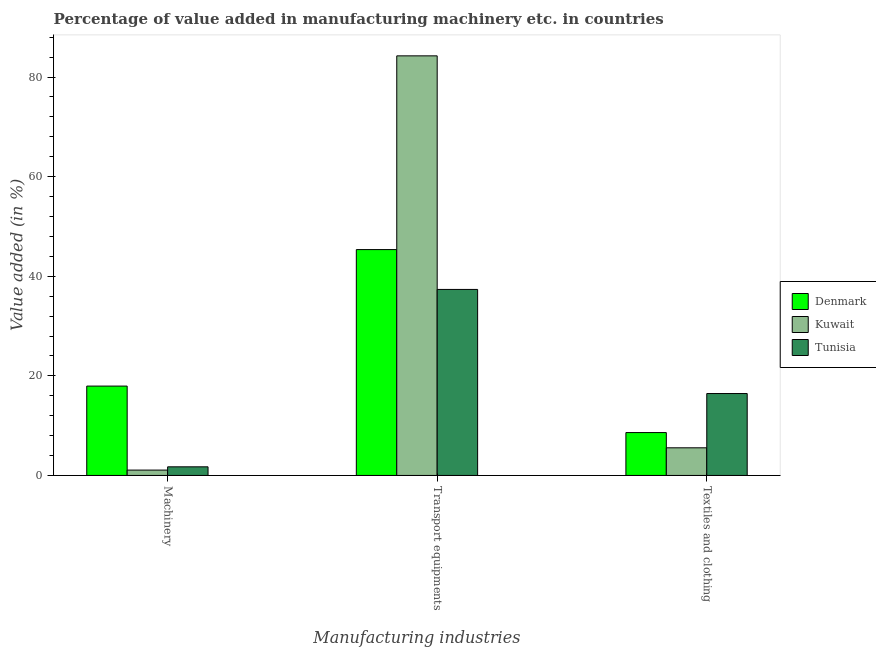How many groups of bars are there?
Your response must be concise. 3. How many bars are there on the 3rd tick from the right?
Your response must be concise. 3. What is the label of the 3rd group of bars from the left?
Provide a short and direct response. Textiles and clothing. What is the value added in manufacturing textile and clothing in Denmark?
Keep it short and to the point. 8.61. Across all countries, what is the maximum value added in manufacturing machinery?
Ensure brevity in your answer.  17.94. Across all countries, what is the minimum value added in manufacturing machinery?
Your answer should be compact. 1.08. In which country was the value added in manufacturing transport equipments maximum?
Keep it short and to the point. Kuwait. In which country was the value added in manufacturing machinery minimum?
Your answer should be compact. Kuwait. What is the total value added in manufacturing textile and clothing in the graph?
Your answer should be compact. 30.6. What is the difference between the value added in manufacturing textile and clothing in Tunisia and that in Denmark?
Give a very brief answer. 7.84. What is the difference between the value added in manufacturing transport equipments in Kuwait and the value added in manufacturing machinery in Denmark?
Give a very brief answer. 66.32. What is the average value added in manufacturing textile and clothing per country?
Your answer should be compact. 10.2. What is the difference between the value added in manufacturing machinery and value added in manufacturing transport equipments in Tunisia?
Offer a very short reply. -35.62. What is the ratio of the value added in manufacturing textile and clothing in Kuwait to that in Denmark?
Provide a succinct answer. 0.64. What is the difference between the highest and the second highest value added in manufacturing transport equipments?
Keep it short and to the point. 38.91. What is the difference between the highest and the lowest value added in manufacturing machinery?
Your answer should be compact. 16.87. Is the sum of the value added in manufacturing textile and clothing in Kuwait and Tunisia greater than the maximum value added in manufacturing machinery across all countries?
Your response must be concise. Yes. What does the 3rd bar from the left in Textiles and clothing represents?
Your answer should be very brief. Tunisia. What does the 2nd bar from the right in Textiles and clothing represents?
Give a very brief answer. Kuwait. How many bars are there?
Ensure brevity in your answer.  9. Are all the bars in the graph horizontal?
Your response must be concise. No. What is the difference between two consecutive major ticks on the Y-axis?
Give a very brief answer. 20. Are the values on the major ticks of Y-axis written in scientific E-notation?
Make the answer very short. No. Does the graph contain any zero values?
Give a very brief answer. No. Does the graph contain grids?
Provide a short and direct response. No. How many legend labels are there?
Give a very brief answer. 3. How are the legend labels stacked?
Offer a very short reply. Vertical. What is the title of the graph?
Offer a terse response. Percentage of value added in manufacturing machinery etc. in countries. What is the label or title of the X-axis?
Keep it short and to the point. Manufacturing industries. What is the label or title of the Y-axis?
Offer a very short reply. Value added (in %). What is the Value added (in %) of Denmark in Machinery?
Provide a succinct answer. 17.94. What is the Value added (in %) in Kuwait in Machinery?
Offer a terse response. 1.08. What is the Value added (in %) in Tunisia in Machinery?
Offer a very short reply. 1.73. What is the Value added (in %) in Denmark in Transport equipments?
Your answer should be compact. 45.36. What is the Value added (in %) in Kuwait in Transport equipments?
Give a very brief answer. 84.26. What is the Value added (in %) of Tunisia in Transport equipments?
Offer a very short reply. 37.36. What is the Value added (in %) of Denmark in Textiles and clothing?
Offer a very short reply. 8.61. What is the Value added (in %) of Kuwait in Textiles and clothing?
Offer a very short reply. 5.55. What is the Value added (in %) in Tunisia in Textiles and clothing?
Keep it short and to the point. 16.45. Across all Manufacturing industries, what is the maximum Value added (in %) in Denmark?
Give a very brief answer. 45.36. Across all Manufacturing industries, what is the maximum Value added (in %) of Kuwait?
Offer a very short reply. 84.26. Across all Manufacturing industries, what is the maximum Value added (in %) of Tunisia?
Your response must be concise. 37.36. Across all Manufacturing industries, what is the minimum Value added (in %) in Denmark?
Offer a very short reply. 8.61. Across all Manufacturing industries, what is the minimum Value added (in %) in Kuwait?
Offer a very short reply. 1.08. Across all Manufacturing industries, what is the minimum Value added (in %) in Tunisia?
Your response must be concise. 1.73. What is the total Value added (in %) in Denmark in the graph?
Give a very brief answer. 71.91. What is the total Value added (in %) in Kuwait in the graph?
Provide a short and direct response. 90.88. What is the total Value added (in %) in Tunisia in the graph?
Ensure brevity in your answer.  55.53. What is the difference between the Value added (in %) of Denmark in Machinery and that in Transport equipments?
Give a very brief answer. -27.41. What is the difference between the Value added (in %) in Kuwait in Machinery and that in Transport equipments?
Keep it short and to the point. -83.19. What is the difference between the Value added (in %) of Tunisia in Machinery and that in Transport equipments?
Your answer should be very brief. -35.62. What is the difference between the Value added (in %) in Denmark in Machinery and that in Textiles and clothing?
Offer a very short reply. 9.33. What is the difference between the Value added (in %) of Kuwait in Machinery and that in Textiles and clothing?
Offer a terse response. -4.47. What is the difference between the Value added (in %) in Tunisia in Machinery and that in Textiles and clothing?
Offer a very short reply. -14.71. What is the difference between the Value added (in %) in Denmark in Transport equipments and that in Textiles and clothing?
Offer a terse response. 36.75. What is the difference between the Value added (in %) in Kuwait in Transport equipments and that in Textiles and clothing?
Your response must be concise. 78.71. What is the difference between the Value added (in %) of Tunisia in Transport equipments and that in Textiles and clothing?
Your response must be concise. 20.91. What is the difference between the Value added (in %) in Denmark in Machinery and the Value added (in %) in Kuwait in Transport equipments?
Your answer should be very brief. -66.32. What is the difference between the Value added (in %) in Denmark in Machinery and the Value added (in %) in Tunisia in Transport equipments?
Provide a short and direct response. -19.41. What is the difference between the Value added (in %) of Kuwait in Machinery and the Value added (in %) of Tunisia in Transport equipments?
Your answer should be compact. -36.28. What is the difference between the Value added (in %) of Denmark in Machinery and the Value added (in %) of Kuwait in Textiles and clothing?
Ensure brevity in your answer.  12.39. What is the difference between the Value added (in %) in Denmark in Machinery and the Value added (in %) in Tunisia in Textiles and clothing?
Offer a very short reply. 1.5. What is the difference between the Value added (in %) in Kuwait in Machinery and the Value added (in %) in Tunisia in Textiles and clothing?
Your response must be concise. -15.37. What is the difference between the Value added (in %) in Denmark in Transport equipments and the Value added (in %) in Kuwait in Textiles and clothing?
Your answer should be very brief. 39.81. What is the difference between the Value added (in %) in Denmark in Transport equipments and the Value added (in %) in Tunisia in Textiles and clothing?
Offer a very short reply. 28.91. What is the difference between the Value added (in %) in Kuwait in Transport equipments and the Value added (in %) in Tunisia in Textiles and clothing?
Keep it short and to the point. 67.81. What is the average Value added (in %) of Denmark per Manufacturing industries?
Provide a succinct answer. 23.97. What is the average Value added (in %) in Kuwait per Manufacturing industries?
Provide a succinct answer. 30.29. What is the average Value added (in %) of Tunisia per Manufacturing industries?
Offer a terse response. 18.51. What is the difference between the Value added (in %) of Denmark and Value added (in %) of Kuwait in Machinery?
Give a very brief answer. 16.87. What is the difference between the Value added (in %) of Denmark and Value added (in %) of Tunisia in Machinery?
Offer a very short reply. 16.21. What is the difference between the Value added (in %) in Kuwait and Value added (in %) in Tunisia in Machinery?
Your response must be concise. -0.66. What is the difference between the Value added (in %) in Denmark and Value added (in %) in Kuwait in Transport equipments?
Make the answer very short. -38.91. What is the difference between the Value added (in %) in Kuwait and Value added (in %) in Tunisia in Transport equipments?
Keep it short and to the point. 46.91. What is the difference between the Value added (in %) in Denmark and Value added (in %) in Kuwait in Textiles and clothing?
Ensure brevity in your answer.  3.06. What is the difference between the Value added (in %) of Denmark and Value added (in %) of Tunisia in Textiles and clothing?
Provide a succinct answer. -7.84. What is the difference between the Value added (in %) in Kuwait and Value added (in %) in Tunisia in Textiles and clothing?
Provide a short and direct response. -10.9. What is the ratio of the Value added (in %) in Denmark in Machinery to that in Transport equipments?
Provide a short and direct response. 0.4. What is the ratio of the Value added (in %) of Kuwait in Machinery to that in Transport equipments?
Your answer should be compact. 0.01. What is the ratio of the Value added (in %) in Tunisia in Machinery to that in Transport equipments?
Offer a terse response. 0.05. What is the ratio of the Value added (in %) of Denmark in Machinery to that in Textiles and clothing?
Make the answer very short. 2.08. What is the ratio of the Value added (in %) of Kuwait in Machinery to that in Textiles and clothing?
Your response must be concise. 0.19. What is the ratio of the Value added (in %) of Tunisia in Machinery to that in Textiles and clothing?
Provide a succinct answer. 0.11. What is the ratio of the Value added (in %) of Denmark in Transport equipments to that in Textiles and clothing?
Ensure brevity in your answer.  5.27. What is the ratio of the Value added (in %) of Kuwait in Transport equipments to that in Textiles and clothing?
Give a very brief answer. 15.19. What is the ratio of the Value added (in %) in Tunisia in Transport equipments to that in Textiles and clothing?
Ensure brevity in your answer.  2.27. What is the difference between the highest and the second highest Value added (in %) of Denmark?
Provide a short and direct response. 27.41. What is the difference between the highest and the second highest Value added (in %) of Kuwait?
Offer a very short reply. 78.71. What is the difference between the highest and the second highest Value added (in %) of Tunisia?
Provide a succinct answer. 20.91. What is the difference between the highest and the lowest Value added (in %) of Denmark?
Make the answer very short. 36.75. What is the difference between the highest and the lowest Value added (in %) in Kuwait?
Your answer should be compact. 83.19. What is the difference between the highest and the lowest Value added (in %) in Tunisia?
Your answer should be compact. 35.62. 